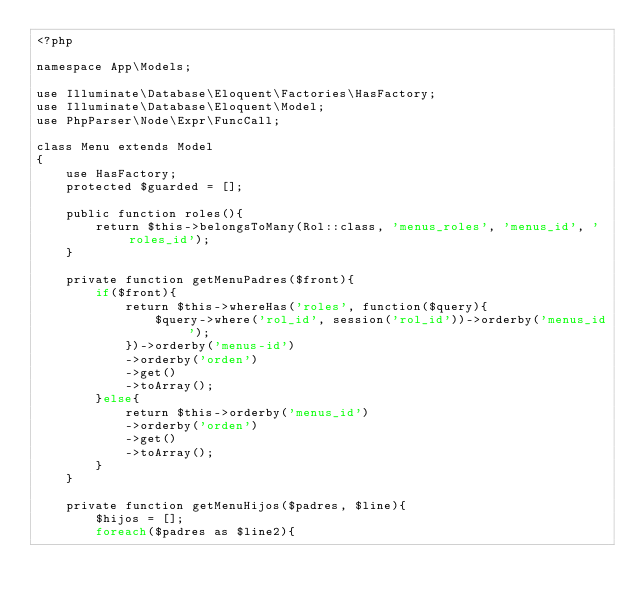Convert code to text. <code><loc_0><loc_0><loc_500><loc_500><_PHP_><?php

namespace App\Models;

use Illuminate\Database\Eloquent\Factories\HasFactory;
use Illuminate\Database\Eloquent\Model;
use PhpParser\Node\Expr\FuncCall;

class Menu extends Model
{
    use HasFactory;
    protected $guarded = [];

    public function roles(){
        return $this->belongsToMany(Rol::class, 'menus_roles', 'menus_id', 'roles_id');
    }

    private function getMenuPadres($front){
        if($front){
            return $this->whereHas('roles', function($query){
                $query->where('rol_id', session('rol_id'))->orderby('menus_id');
            })->orderby('menus-id')
            ->orderby('orden')
            ->get()
            ->toArray();
        }else{
            return $this->orderby('menus_id')
            ->orderby('orden')
            ->get()
            ->toArray();
        }
    }

    private function getMenuHijos($padres, $line){
        $hijos = [];
        foreach($padres as $line2){</code> 